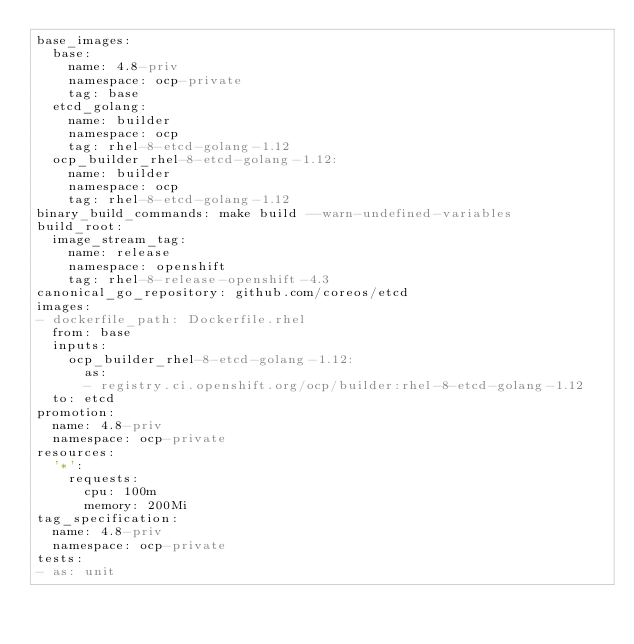Convert code to text. <code><loc_0><loc_0><loc_500><loc_500><_YAML_>base_images:
  base:
    name: 4.8-priv
    namespace: ocp-private
    tag: base
  etcd_golang:
    name: builder
    namespace: ocp
    tag: rhel-8-etcd-golang-1.12
  ocp_builder_rhel-8-etcd-golang-1.12:
    name: builder
    namespace: ocp
    tag: rhel-8-etcd-golang-1.12
binary_build_commands: make build --warn-undefined-variables
build_root:
  image_stream_tag:
    name: release
    namespace: openshift
    tag: rhel-8-release-openshift-4.3
canonical_go_repository: github.com/coreos/etcd
images:
- dockerfile_path: Dockerfile.rhel
  from: base
  inputs:
    ocp_builder_rhel-8-etcd-golang-1.12:
      as:
      - registry.ci.openshift.org/ocp/builder:rhel-8-etcd-golang-1.12
  to: etcd
promotion:
  name: 4.8-priv
  namespace: ocp-private
resources:
  '*':
    requests:
      cpu: 100m
      memory: 200Mi
tag_specification:
  name: 4.8-priv
  namespace: ocp-private
tests:
- as: unit</code> 